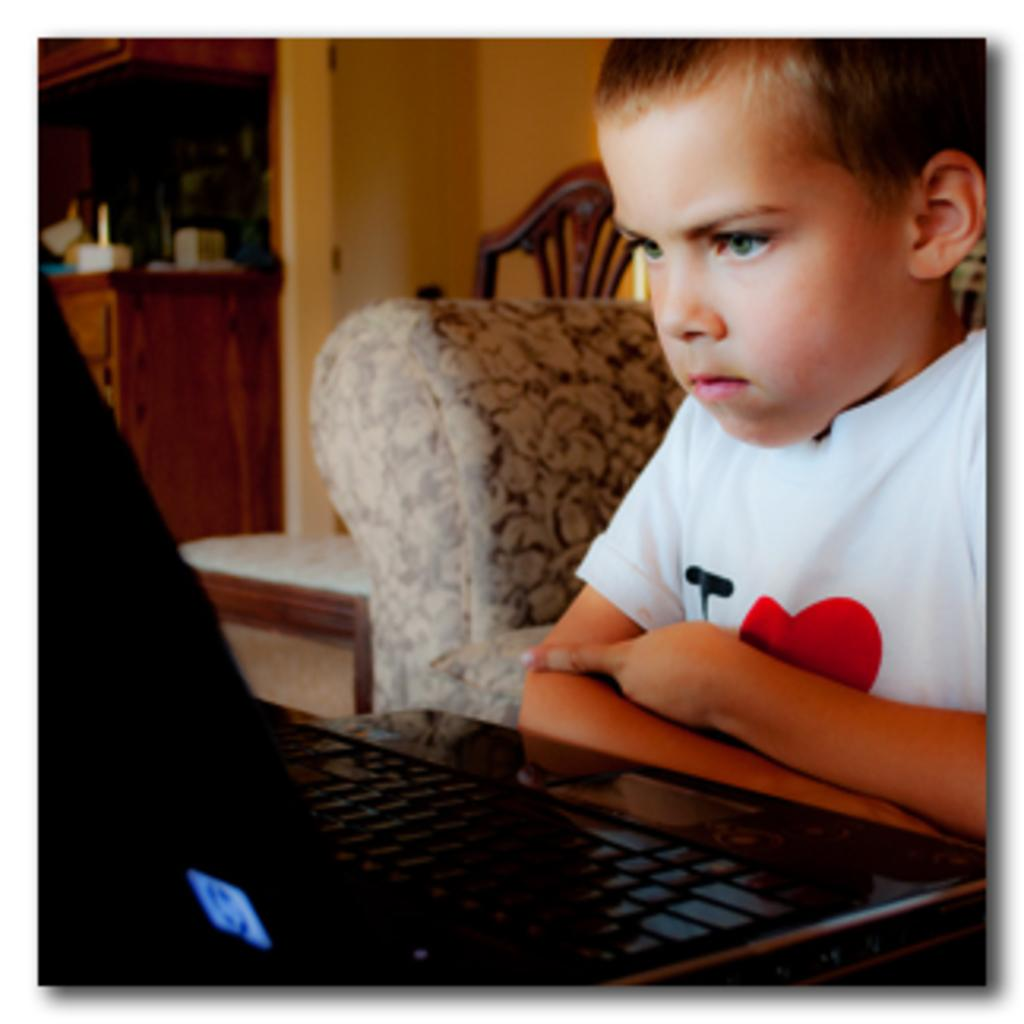Who is the main subject in the image? There is a boy in the image. What is the boy interacting with in the image? A laptop is placed in front of the boy. What can be seen in the background of the image? There are objects placed on a cupboard, a chair, and a couch in the background. What type of produce is the boy holding in the image? There is no produce visible in the image; the boy is interacting with a laptop. 